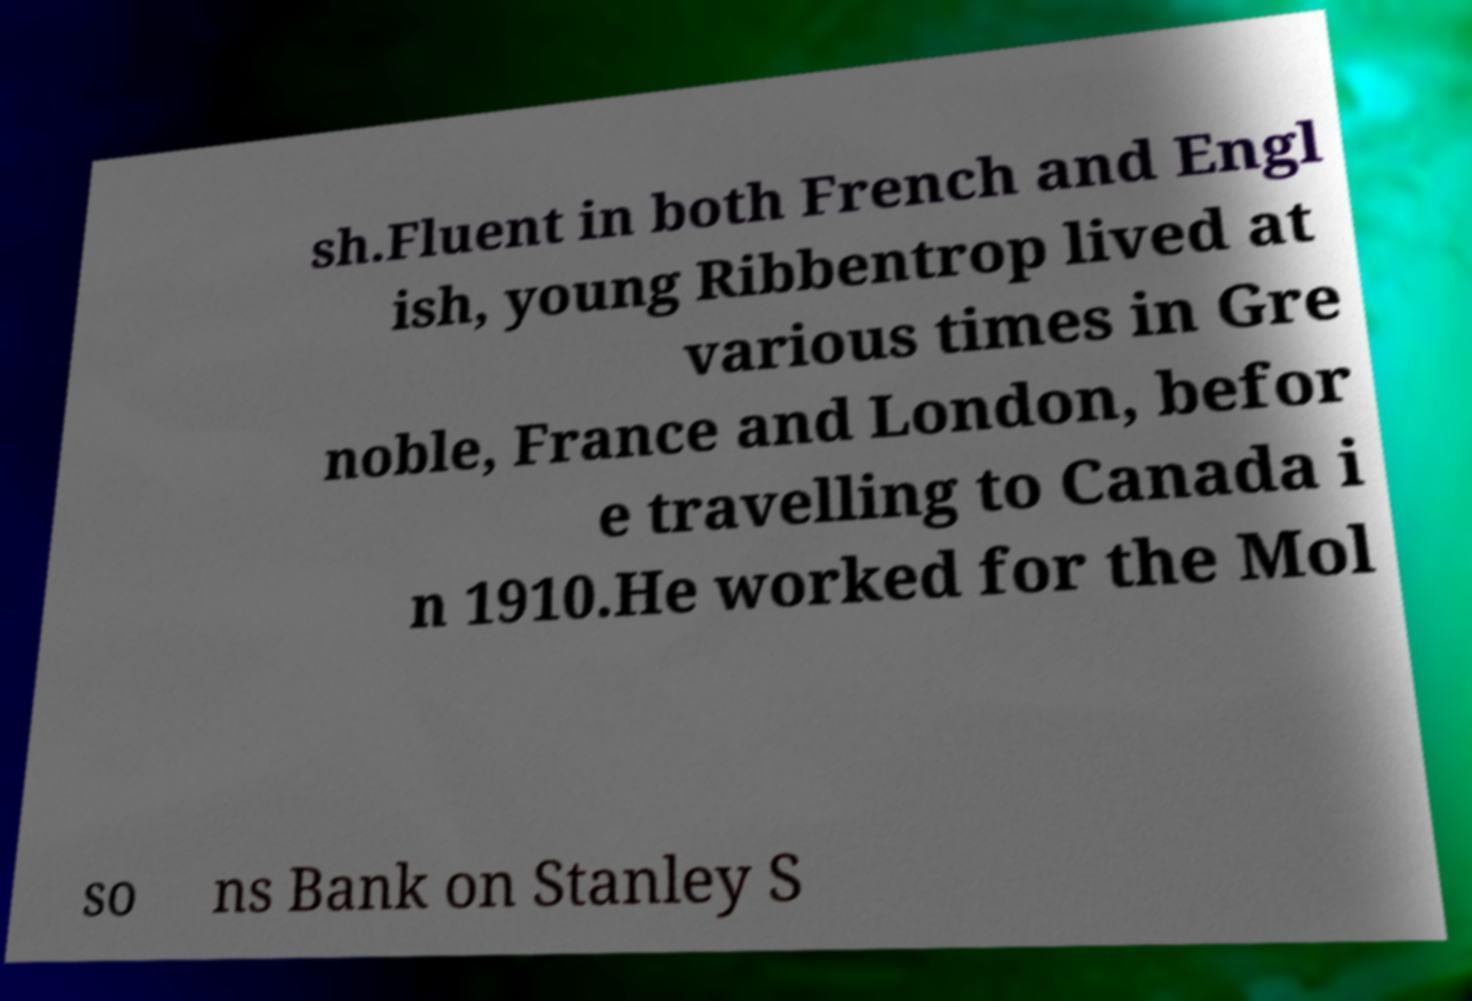Can you accurately transcribe the text from the provided image for me? sh.Fluent in both French and Engl ish, young Ribbentrop lived at various times in Gre noble, France and London, befor e travelling to Canada i n 1910.He worked for the Mol so ns Bank on Stanley S 